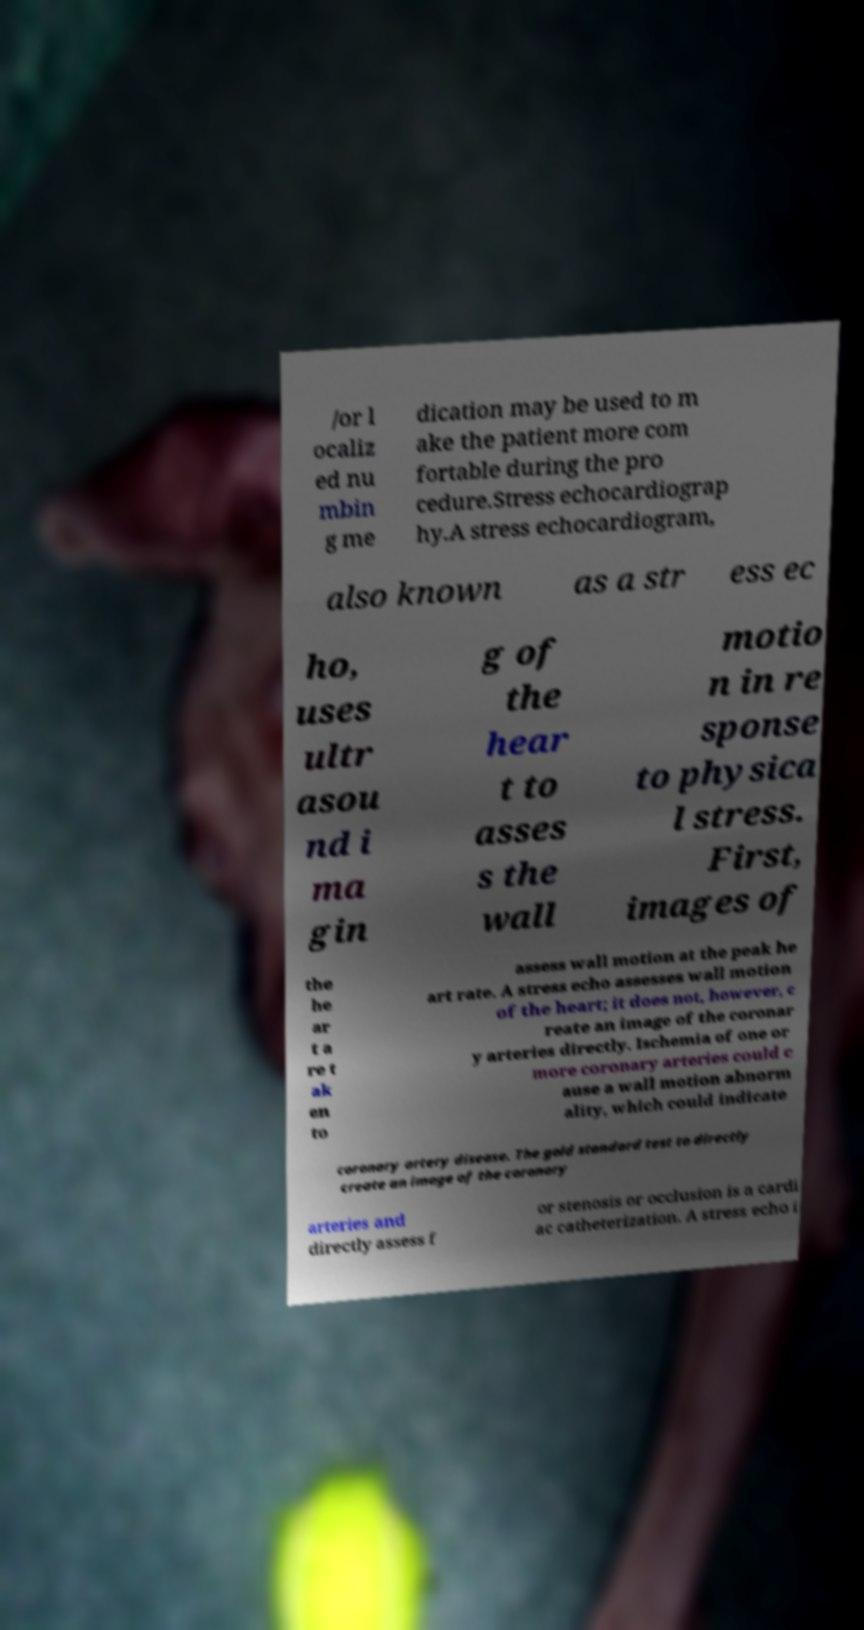There's text embedded in this image that I need extracted. Can you transcribe it verbatim? /or l ocaliz ed nu mbin g me dication may be used to m ake the patient more com fortable during the pro cedure.Stress echocardiograp hy.A stress echocardiogram, also known as a str ess ec ho, uses ultr asou nd i ma gin g of the hear t to asses s the wall motio n in re sponse to physica l stress. First, images of the he ar t a re t ak en to assess wall motion at the peak he art rate. A stress echo assesses wall motion of the heart; it does not, however, c reate an image of the coronar y arteries directly. Ischemia of one or more coronary arteries could c ause a wall motion abnorm ality, which could indicate coronary artery disease. The gold standard test to directly create an image of the coronary arteries and directly assess f or stenosis or occlusion is a cardi ac catheterization. A stress echo i 